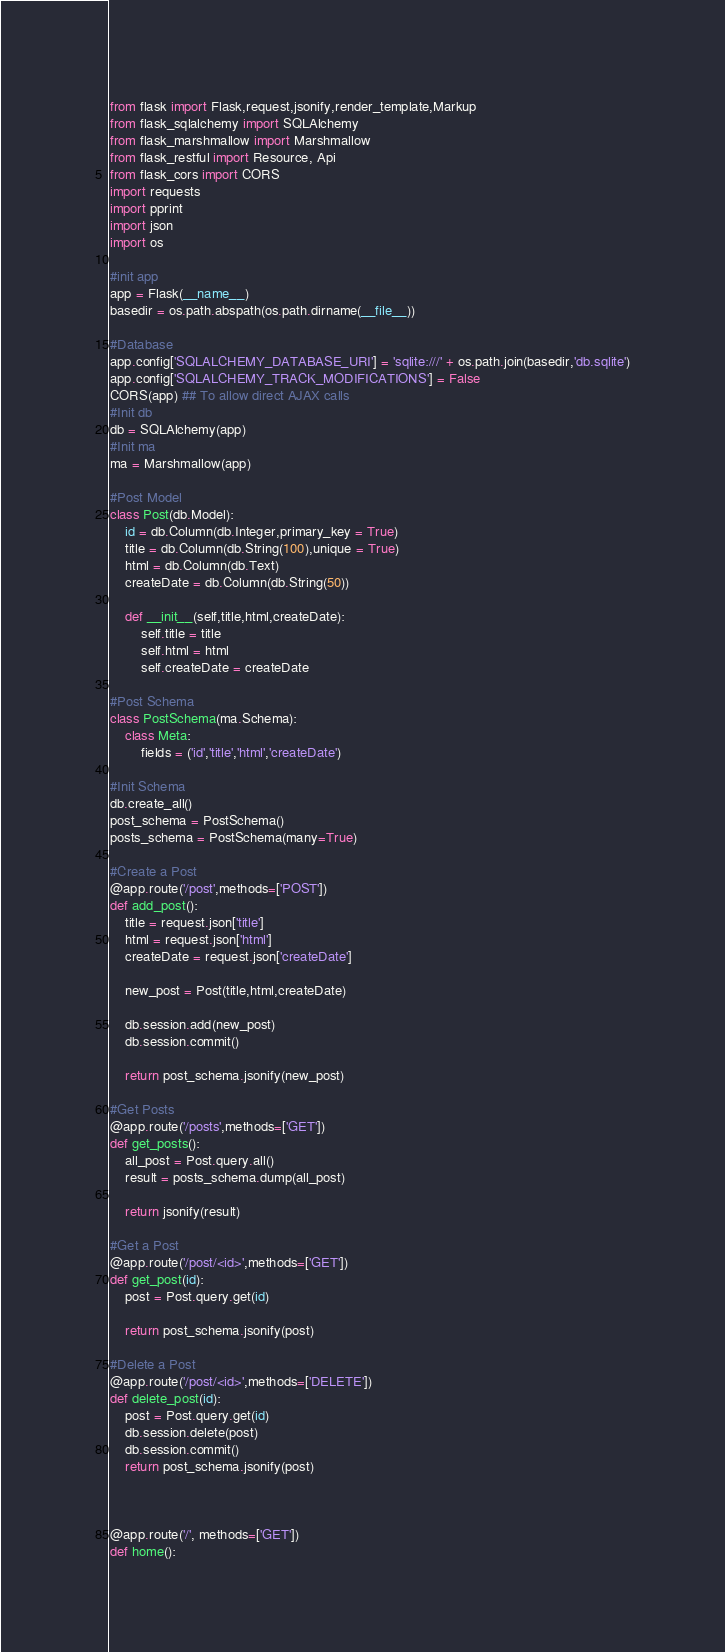<code> <loc_0><loc_0><loc_500><loc_500><_Python_>from flask import Flask,request,jsonify,render_template,Markup
from flask_sqlalchemy import SQLAlchemy
from flask_marshmallow import Marshmallow
from flask_restful import Resource, Api
from flask_cors import CORS
import requests
import pprint
import json
import os

#init app
app = Flask(__name__)
basedir = os.path.abspath(os.path.dirname(__file__))

#Database
app.config['SQLALCHEMY_DATABASE_URI'] = 'sqlite:///' + os.path.join(basedir,'db.sqlite')
app.config['SQLALCHEMY_TRACK_MODIFICATIONS'] = False
CORS(app) ## To allow direct AJAX calls
#Init db
db = SQLAlchemy(app)
#Init ma
ma = Marshmallow(app)

#Post Model
class Post(db.Model):
    id = db.Column(db.Integer,primary_key = True)
    title = db.Column(db.String(100),unique = True)
    html = db.Column(db.Text)
    createDate = db.Column(db.String(50))

    def __init__(self,title,html,createDate):
        self.title = title
        self.html = html
        self.createDate = createDate

#Post Schema
class PostSchema(ma.Schema):
    class Meta:
        fields = ('id','title','html','createDate')

#Init Schema
db.create_all()
post_schema = PostSchema()
posts_schema = PostSchema(many=True)

#Create a Post
@app.route('/post',methods=['POST'])
def add_post():
    title = request.json['title']
    html = request.json['html']
    createDate = request.json['createDate']

    new_post = Post(title,html,createDate)

    db.session.add(new_post)
    db.session.commit()
    
    return post_schema.jsonify(new_post)

#Get Posts
@app.route('/posts',methods=['GET'])
def get_posts():
    all_post = Post.query.all()
    result = posts_schema.dump(all_post)

    return jsonify(result)

#Get a Post
@app.route('/post/<id>',methods=['GET'])
def get_post(id):
    post = Post.query.get(id)

    return post_schema.jsonify(post)

#Delete a Post
@app.route('/post/<id>',methods=['DELETE'])
def delete_post(id):
    post = Post.query.get(id)
    db.session.delete(post)
    db.session.commit()
    return post_schema.jsonify(post)


 
@app.route('/', methods=['GET'])
def home():</code> 